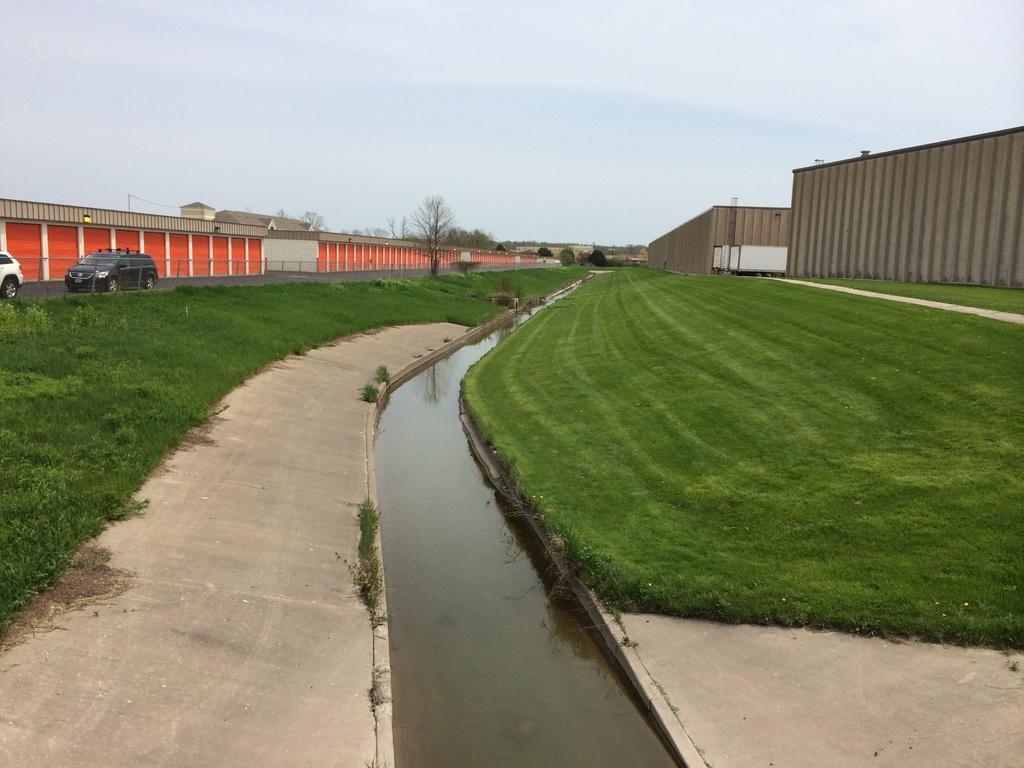Please provide a concise description of this image. In this image I can see few vehicles,trees,fencing,containers in orange and brown color. The sky is in white and blue color. 